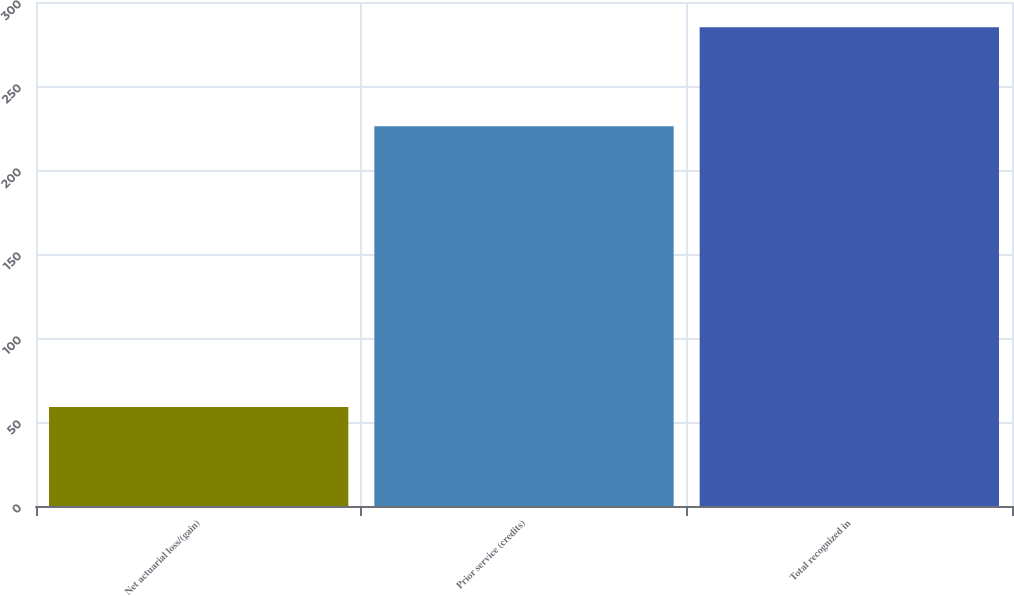<chart> <loc_0><loc_0><loc_500><loc_500><bar_chart><fcel>Net actuarial loss/(gain)<fcel>Prior service (credits)<fcel>Total recognized in<nl><fcel>59<fcel>226<fcel>285<nl></chart> 